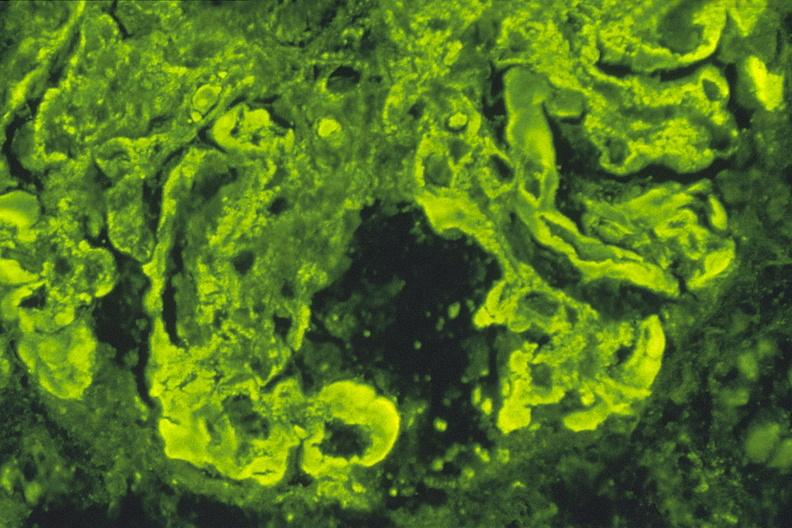where is this?
Answer the question using a single word or phrase. Urinary 